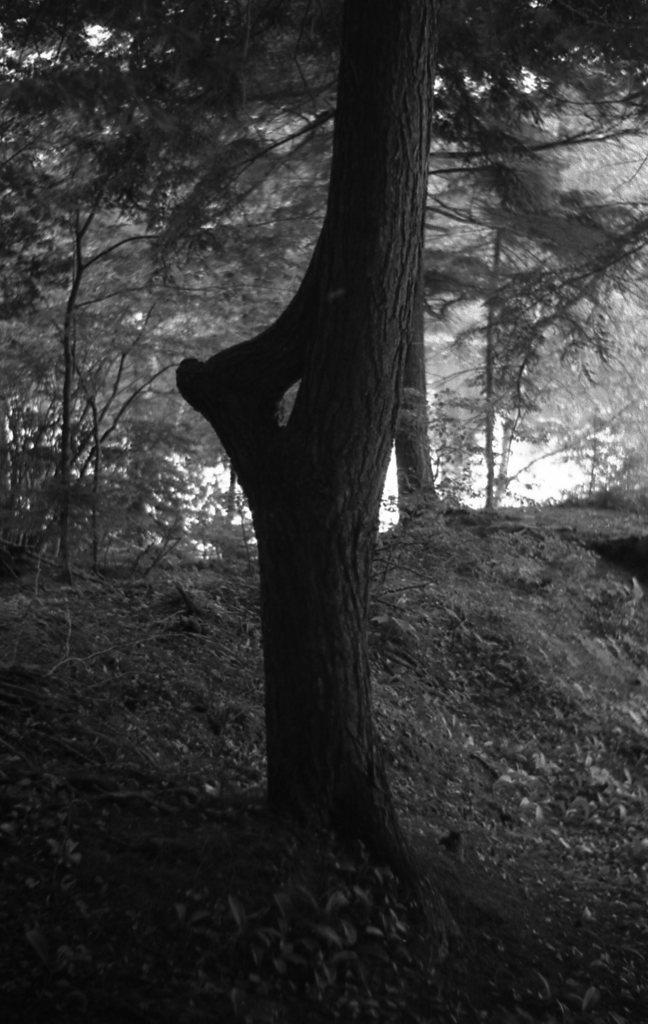In one or two sentences, can you explain what this image depicts? This is a black and white where we can see so many trees on the ground. 